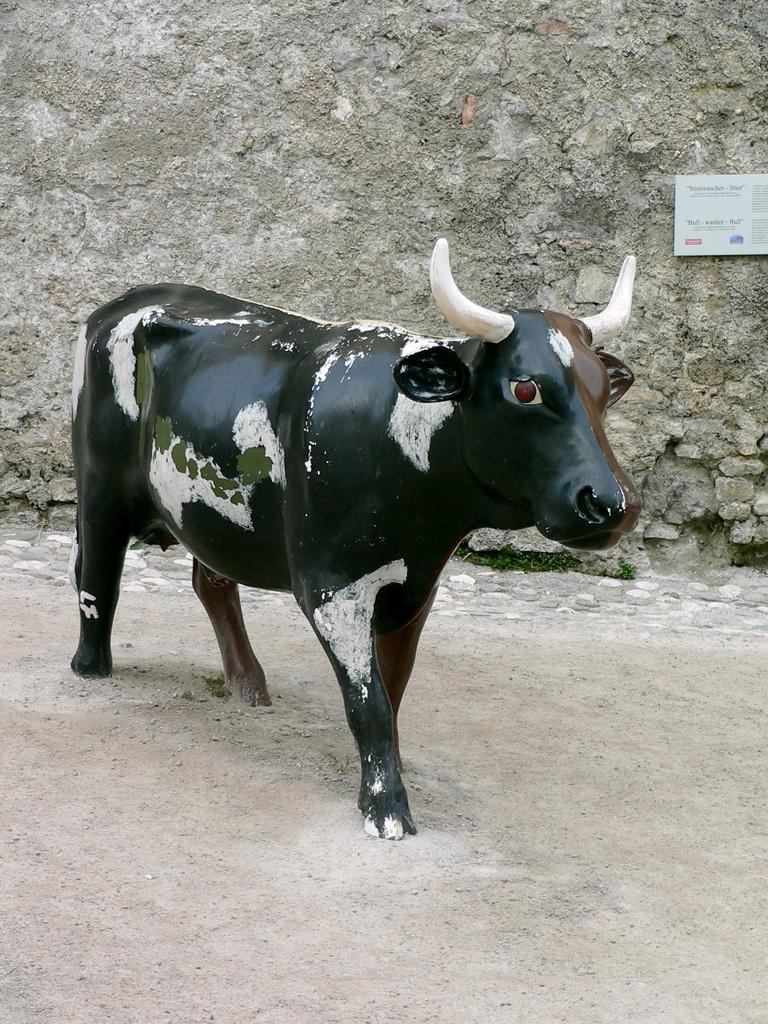Describe this image in one or two sentences. In this image there is a statue of a cow, behind the statue there is a wall. 